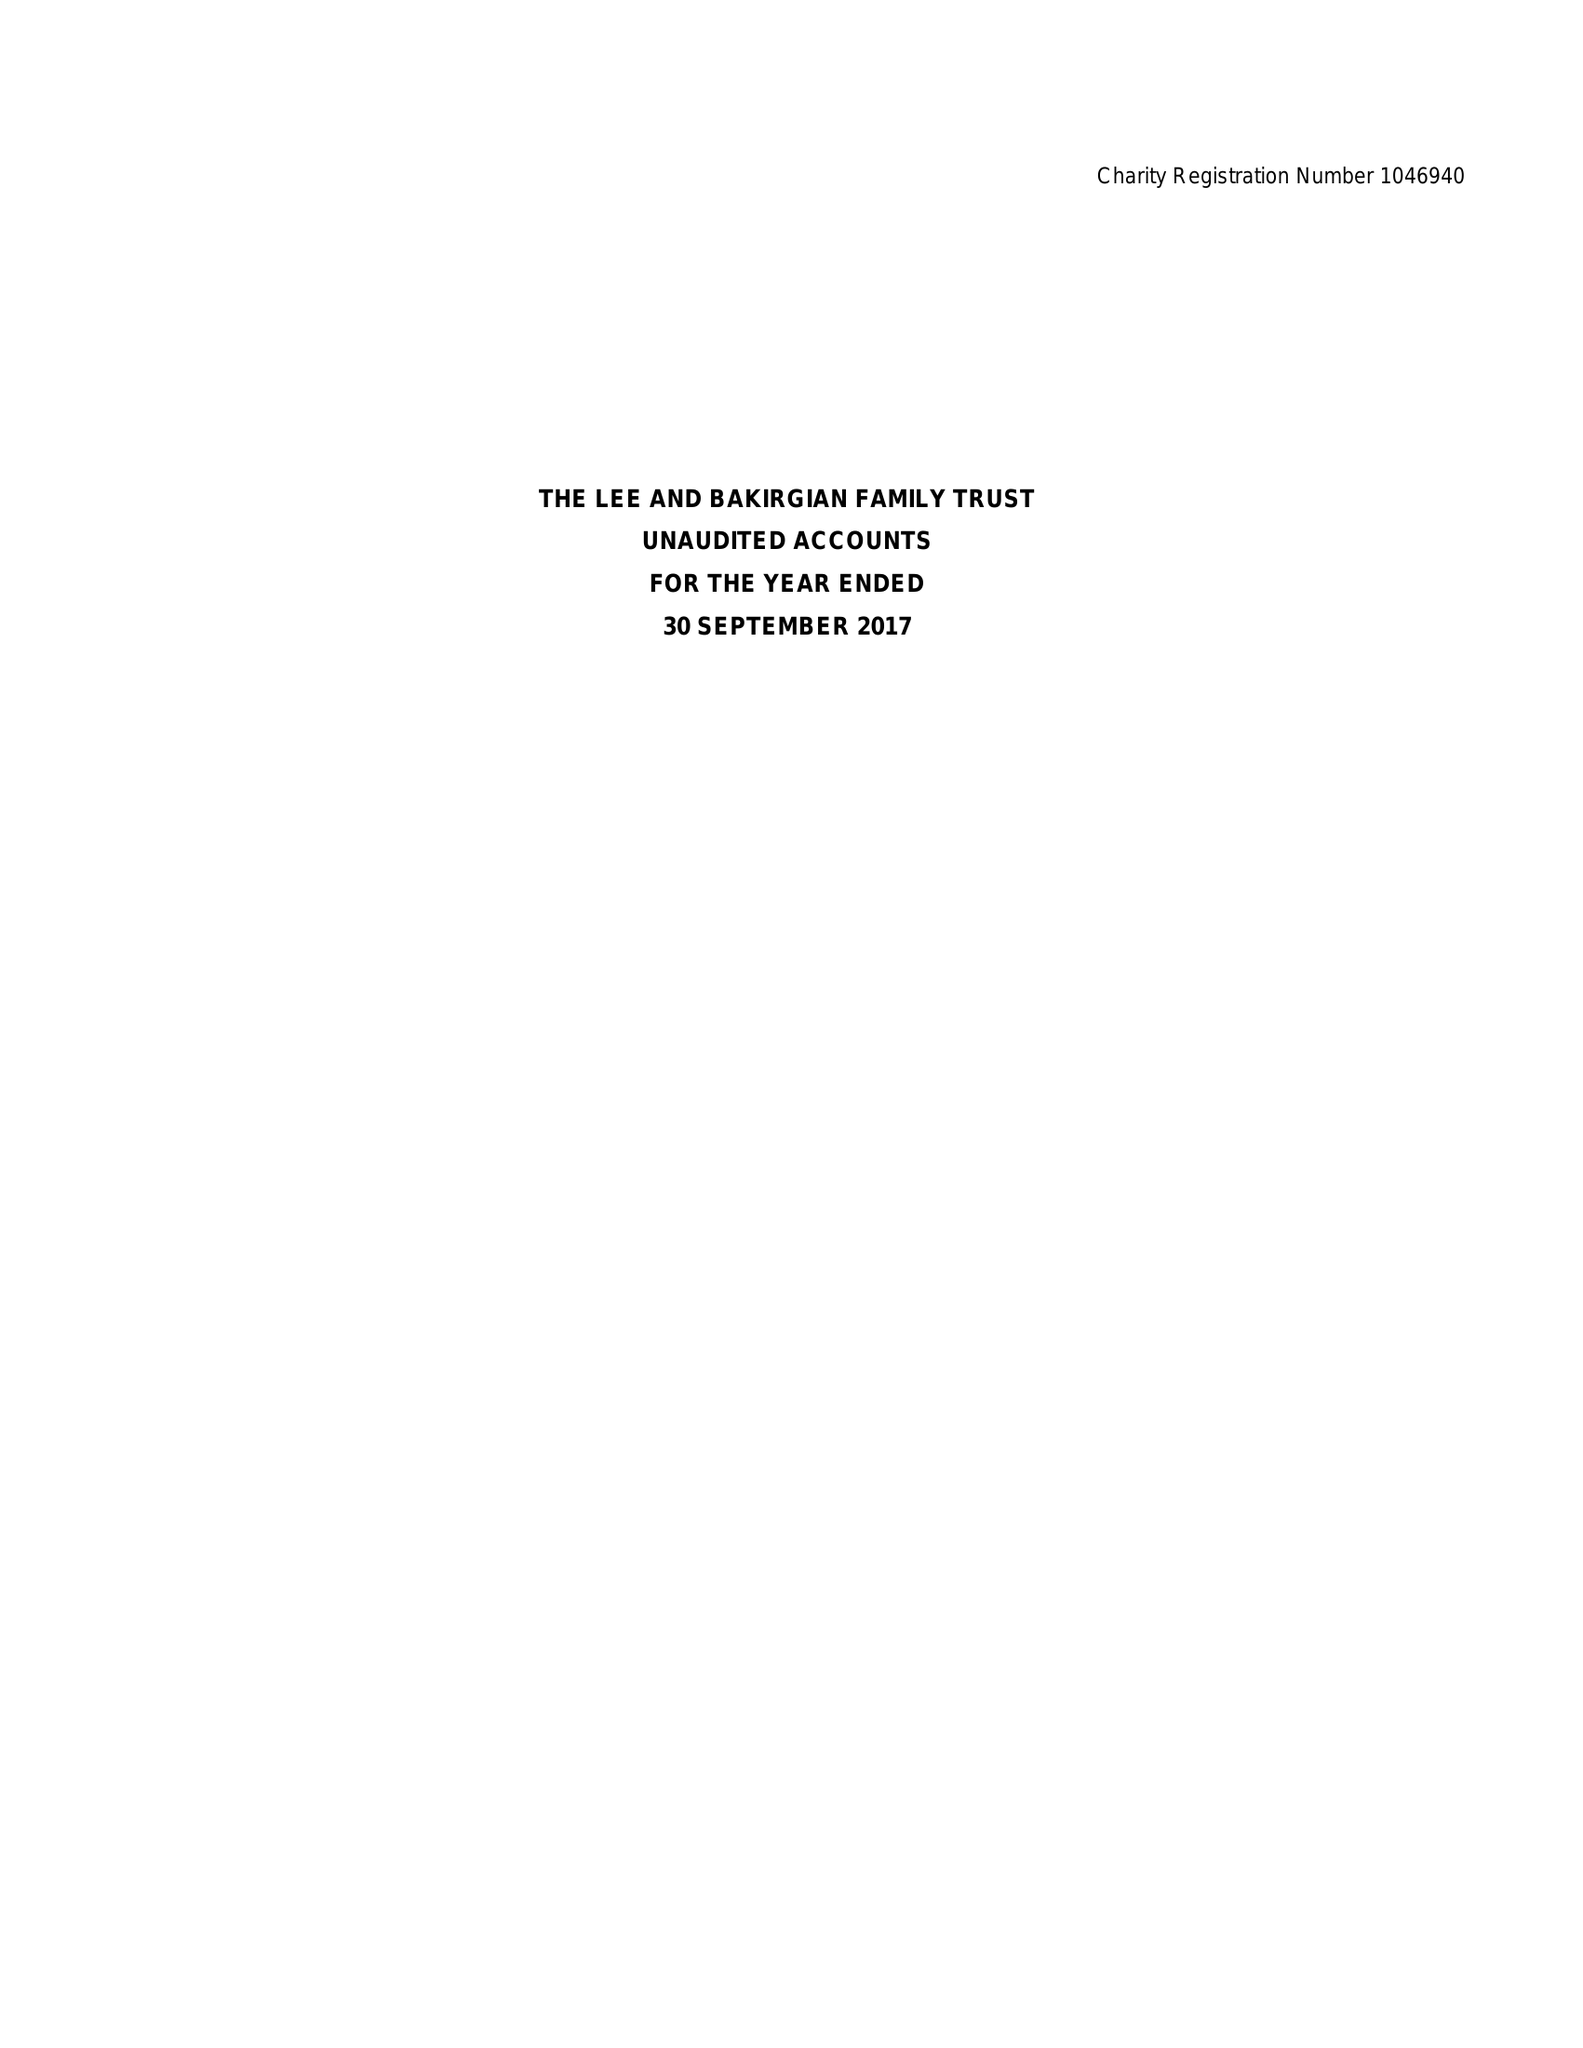What is the value for the address__postcode?
Answer the question using a single word or phrase. WA3 3JD 